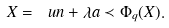Convert formula to latex. <formula><loc_0><loc_0><loc_500><loc_500>X = \ u n + \lambda a \prec \Phi _ { q } ( X ) .</formula> 